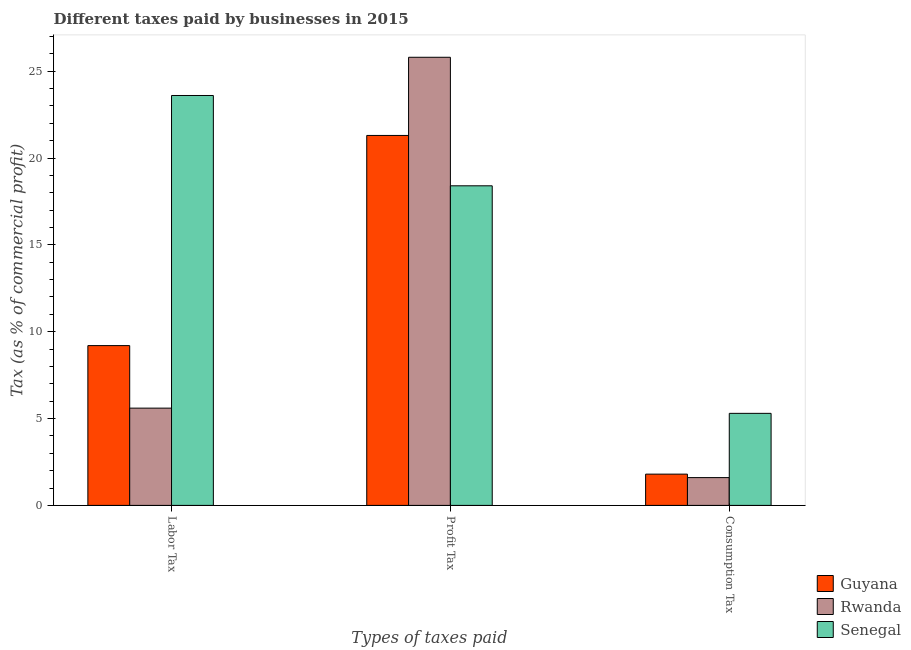How many different coloured bars are there?
Your answer should be compact. 3. Are the number of bars per tick equal to the number of legend labels?
Your response must be concise. Yes. How many bars are there on the 3rd tick from the left?
Your answer should be compact. 3. How many bars are there on the 1st tick from the right?
Provide a short and direct response. 3. What is the label of the 1st group of bars from the left?
Offer a terse response. Labor Tax. What is the percentage of consumption tax in Rwanda?
Your answer should be very brief. 1.6. Across all countries, what is the minimum percentage of labor tax?
Your answer should be very brief. 5.6. In which country was the percentage of labor tax maximum?
Offer a terse response. Senegal. In which country was the percentage of consumption tax minimum?
Make the answer very short. Rwanda. What is the total percentage of labor tax in the graph?
Give a very brief answer. 38.4. What is the difference between the percentage of profit tax in Guyana and that in Senegal?
Your answer should be very brief. 2.9. What is the difference between the percentage of consumption tax in Senegal and the percentage of labor tax in Rwanda?
Ensure brevity in your answer.  -0.3. What is the average percentage of consumption tax per country?
Provide a succinct answer. 2.9. What is the difference between the percentage of consumption tax and percentage of labor tax in Rwanda?
Offer a terse response. -4. In how many countries, is the percentage of labor tax greater than 12 %?
Ensure brevity in your answer.  1. What is the ratio of the percentage of profit tax in Senegal to that in Rwanda?
Offer a terse response. 0.71. Is the difference between the percentage of labor tax in Senegal and Guyana greater than the difference between the percentage of consumption tax in Senegal and Guyana?
Ensure brevity in your answer.  Yes. What is the difference between the highest and the second highest percentage of consumption tax?
Provide a short and direct response. 3.5. What is the difference between the highest and the lowest percentage of consumption tax?
Give a very brief answer. 3.7. Is the sum of the percentage of profit tax in Senegal and Guyana greater than the maximum percentage of labor tax across all countries?
Give a very brief answer. Yes. What does the 1st bar from the left in Consumption Tax represents?
Make the answer very short. Guyana. What does the 2nd bar from the right in Consumption Tax represents?
Your response must be concise. Rwanda. How many bars are there?
Ensure brevity in your answer.  9. How many countries are there in the graph?
Your answer should be compact. 3. What is the difference between two consecutive major ticks on the Y-axis?
Make the answer very short. 5. Where does the legend appear in the graph?
Provide a short and direct response. Bottom right. How many legend labels are there?
Your response must be concise. 3. What is the title of the graph?
Offer a terse response. Different taxes paid by businesses in 2015. What is the label or title of the X-axis?
Offer a very short reply. Types of taxes paid. What is the label or title of the Y-axis?
Provide a succinct answer. Tax (as % of commercial profit). What is the Tax (as % of commercial profit) in Rwanda in Labor Tax?
Your answer should be compact. 5.6. What is the Tax (as % of commercial profit) of Senegal in Labor Tax?
Offer a terse response. 23.6. What is the Tax (as % of commercial profit) of Guyana in Profit Tax?
Your response must be concise. 21.3. What is the Tax (as % of commercial profit) of Rwanda in Profit Tax?
Your answer should be very brief. 25.8. What is the Tax (as % of commercial profit) of Senegal in Profit Tax?
Offer a very short reply. 18.4. What is the Tax (as % of commercial profit) in Guyana in Consumption Tax?
Make the answer very short. 1.8. What is the Tax (as % of commercial profit) of Senegal in Consumption Tax?
Your answer should be very brief. 5.3. Across all Types of taxes paid, what is the maximum Tax (as % of commercial profit) in Guyana?
Give a very brief answer. 21.3. Across all Types of taxes paid, what is the maximum Tax (as % of commercial profit) in Rwanda?
Your response must be concise. 25.8. Across all Types of taxes paid, what is the maximum Tax (as % of commercial profit) in Senegal?
Make the answer very short. 23.6. Across all Types of taxes paid, what is the minimum Tax (as % of commercial profit) in Guyana?
Your answer should be compact. 1.8. Across all Types of taxes paid, what is the minimum Tax (as % of commercial profit) in Rwanda?
Your answer should be compact. 1.6. What is the total Tax (as % of commercial profit) of Guyana in the graph?
Offer a very short reply. 32.3. What is the total Tax (as % of commercial profit) in Senegal in the graph?
Your answer should be very brief. 47.3. What is the difference between the Tax (as % of commercial profit) in Guyana in Labor Tax and that in Profit Tax?
Keep it short and to the point. -12.1. What is the difference between the Tax (as % of commercial profit) of Rwanda in Labor Tax and that in Profit Tax?
Provide a short and direct response. -20.2. What is the difference between the Tax (as % of commercial profit) of Senegal in Labor Tax and that in Profit Tax?
Offer a very short reply. 5.2. What is the difference between the Tax (as % of commercial profit) of Guyana in Labor Tax and that in Consumption Tax?
Your response must be concise. 7.4. What is the difference between the Tax (as % of commercial profit) in Rwanda in Profit Tax and that in Consumption Tax?
Offer a terse response. 24.2. What is the difference between the Tax (as % of commercial profit) of Guyana in Labor Tax and the Tax (as % of commercial profit) of Rwanda in Profit Tax?
Your answer should be very brief. -16.6. What is the difference between the Tax (as % of commercial profit) in Rwanda in Labor Tax and the Tax (as % of commercial profit) in Senegal in Consumption Tax?
Provide a short and direct response. 0.3. What is the difference between the Tax (as % of commercial profit) of Guyana in Profit Tax and the Tax (as % of commercial profit) of Rwanda in Consumption Tax?
Ensure brevity in your answer.  19.7. What is the difference between the Tax (as % of commercial profit) in Guyana in Profit Tax and the Tax (as % of commercial profit) in Senegal in Consumption Tax?
Give a very brief answer. 16. What is the difference between the Tax (as % of commercial profit) of Rwanda in Profit Tax and the Tax (as % of commercial profit) of Senegal in Consumption Tax?
Provide a short and direct response. 20.5. What is the average Tax (as % of commercial profit) of Guyana per Types of taxes paid?
Provide a short and direct response. 10.77. What is the average Tax (as % of commercial profit) of Rwanda per Types of taxes paid?
Your answer should be very brief. 11. What is the average Tax (as % of commercial profit) in Senegal per Types of taxes paid?
Ensure brevity in your answer.  15.77. What is the difference between the Tax (as % of commercial profit) of Guyana and Tax (as % of commercial profit) of Senegal in Labor Tax?
Your answer should be very brief. -14.4. What is the difference between the Tax (as % of commercial profit) in Rwanda and Tax (as % of commercial profit) in Senegal in Labor Tax?
Offer a terse response. -18. What is the difference between the Tax (as % of commercial profit) of Guyana and Tax (as % of commercial profit) of Rwanda in Profit Tax?
Keep it short and to the point. -4.5. What is the difference between the Tax (as % of commercial profit) in Rwanda and Tax (as % of commercial profit) in Senegal in Profit Tax?
Offer a very short reply. 7.4. What is the difference between the Tax (as % of commercial profit) in Guyana and Tax (as % of commercial profit) in Senegal in Consumption Tax?
Provide a succinct answer. -3.5. What is the ratio of the Tax (as % of commercial profit) of Guyana in Labor Tax to that in Profit Tax?
Your answer should be compact. 0.43. What is the ratio of the Tax (as % of commercial profit) of Rwanda in Labor Tax to that in Profit Tax?
Offer a very short reply. 0.22. What is the ratio of the Tax (as % of commercial profit) in Senegal in Labor Tax to that in Profit Tax?
Ensure brevity in your answer.  1.28. What is the ratio of the Tax (as % of commercial profit) in Guyana in Labor Tax to that in Consumption Tax?
Provide a succinct answer. 5.11. What is the ratio of the Tax (as % of commercial profit) in Rwanda in Labor Tax to that in Consumption Tax?
Provide a short and direct response. 3.5. What is the ratio of the Tax (as % of commercial profit) of Senegal in Labor Tax to that in Consumption Tax?
Offer a very short reply. 4.45. What is the ratio of the Tax (as % of commercial profit) of Guyana in Profit Tax to that in Consumption Tax?
Your answer should be compact. 11.83. What is the ratio of the Tax (as % of commercial profit) in Rwanda in Profit Tax to that in Consumption Tax?
Your answer should be very brief. 16.12. What is the ratio of the Tax (as % of commercial profit) of Senegal in Profit Tax to that in Consumption Tax?
Offer a terse response. 3.47. What is the difference between the highest and the second highest Tax (as % of commercial profit) in Rwanda?
Your response must be concise. 20.2. What is the difference between the highest and the second highest Tax (as % of commercial profit) of Senegal?
Ensure brevity in your answer.  5.2. What is the difference between the highest and the lowest Tax (as % of commercial profit) of Guyana?
Your answer should be very brief. 19.5. What is the difference between the highest and the lowest Tax (as % of commercial profit) in Rwanda?
Ensure brevity in your answer.  24.2. 